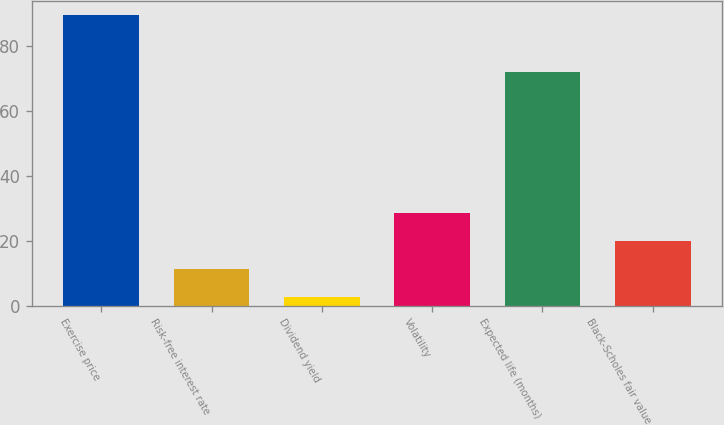Convert chart. <chart><loc_0><loc_0><loc_500><loc_500><bar_chart><fcel>Exercise price<fcel>Risk-free interest rate<fcel>Dividend yield<fcel>Volatility<fcel>Expected life (months)<fcel>Black-Scholes fair value<nl><fcel>89.47<fcel>11.29<fcel>2.6<fcel>28.67<fcel>72<fcel>19.98<nl></chart> 